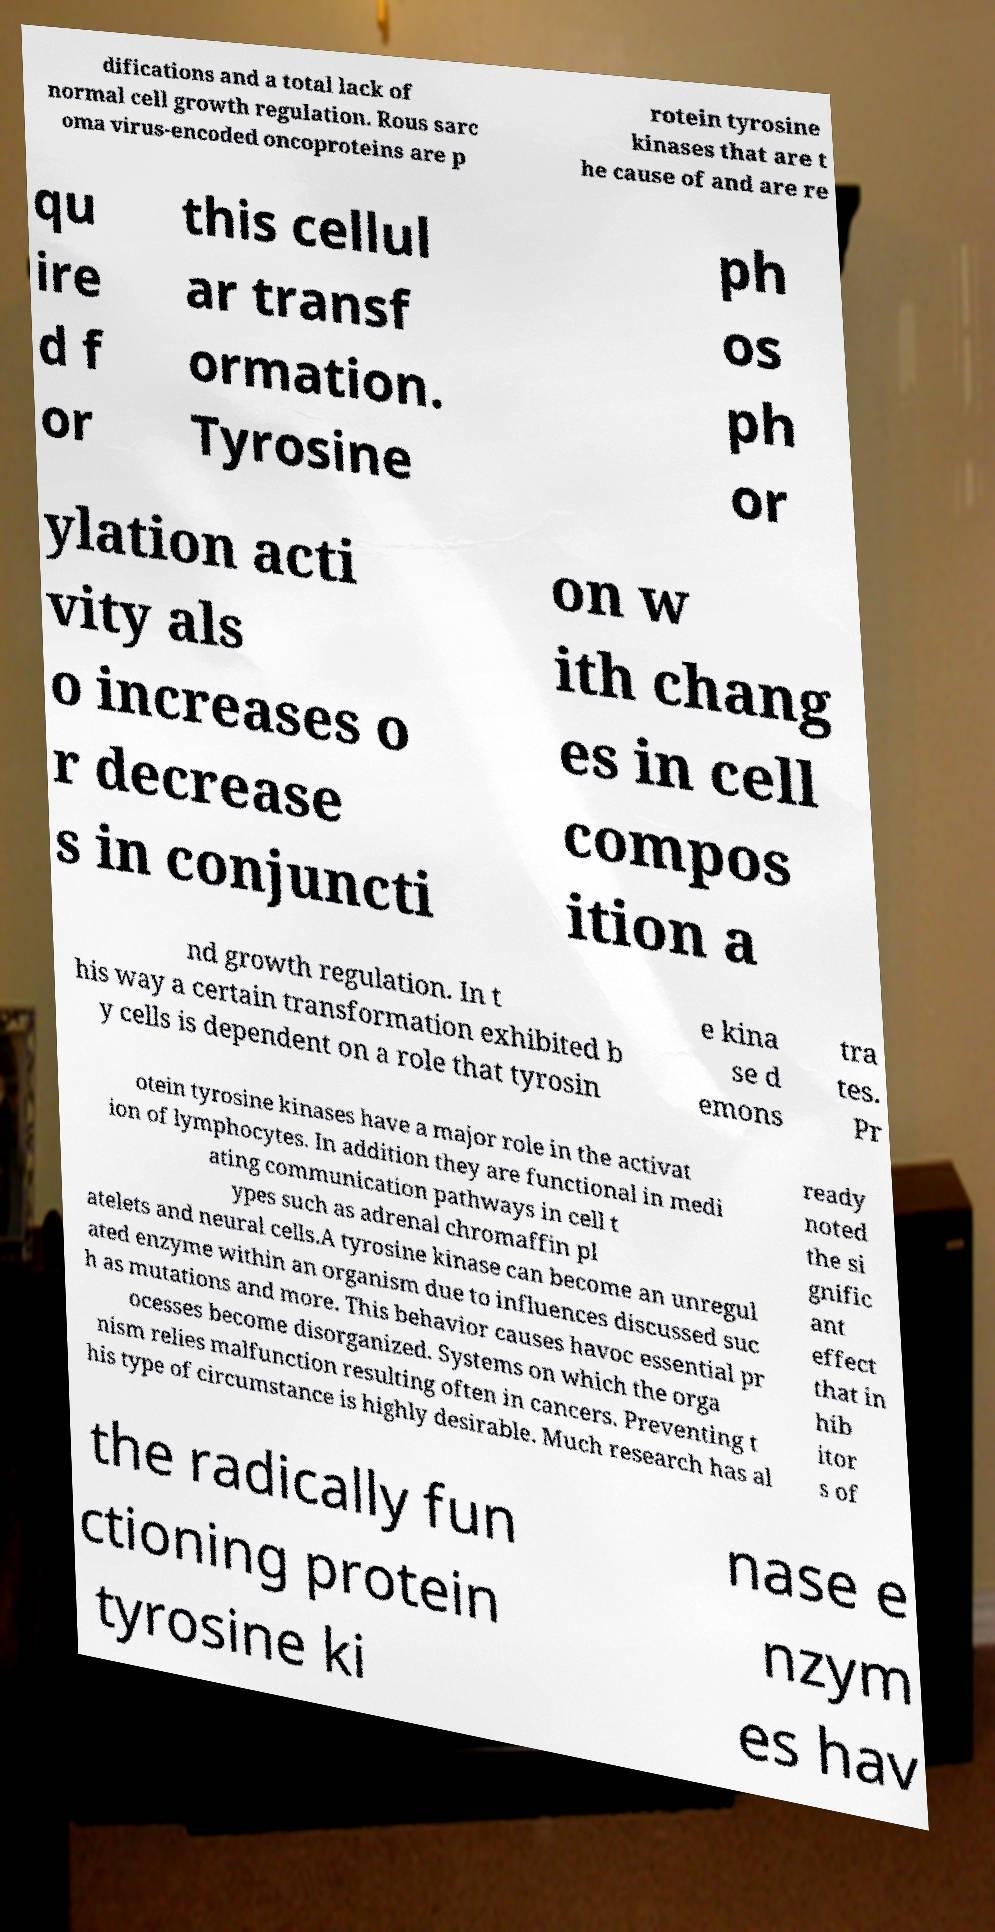Can you read and provide the text displayed in the image?This photo seems to have some interesting text. Can you extract and type it out for me? difications and a total lack of normal cell growth regulation. Rous sarc oma virus-encoded oncoproteins are p rotein tyrosine kinases that are t he cause of and are re qu ire d f or this cellul ar transf ormation. Tyrosine ph os ph or ylation acti vity als o increases o r decrease s in conjuncti on w ith chang es in cell compos ition a nd growth regulation. In t his way a certain transformation exhibited b y cells is dependent on a role that tyrosin e kina se d emons tra tes. Pr otein tyrosine kinases have a major role in the activat ion of lymphocytes. In addition they are functional in medi ating communication pathways in cell t ypes such as adrenal chromaffin pl atelets and neural cells.A tyrosine kinase can become an unregul ated enzyme within an organism due to influences discussed suc h as mutations and more. This behavior causes havoc essential pr ocesses become disorganized. Systems on which the orga nism relies malfunction resulting often in cancers. Preventing t his type of circumstance is highly desirable. Much research has al ready noted the si gnific ant effect that in hib itor s of the radically fun ctioning protein tyrosine ki nase e nzym es hav 